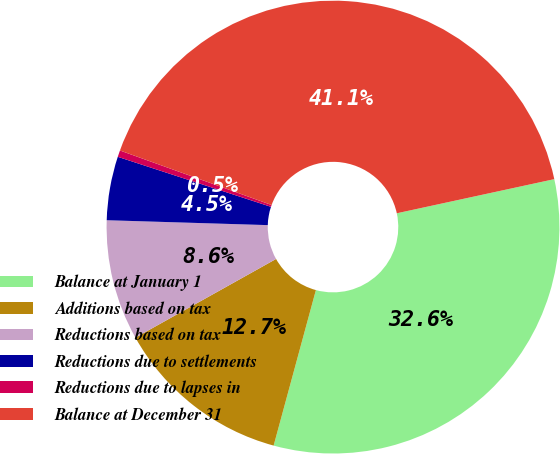Convert chart to OTSL. <chart><loc_0><loc_0><loc_500><loc_500><pie_chart><fcel>Balance at January 1<fcel>Additions based on tax<fcel>Reductions based on tax<fcel>Reductions due to settlements<fcel>Reductions due to lapses in<fcel>Balance at December 31<nl><fcel>32.62%<fcel>12.66%<fcel>8.6%<fcel>4.54%<fcel>0.47%<fcel>41.11%<nl></chart> 